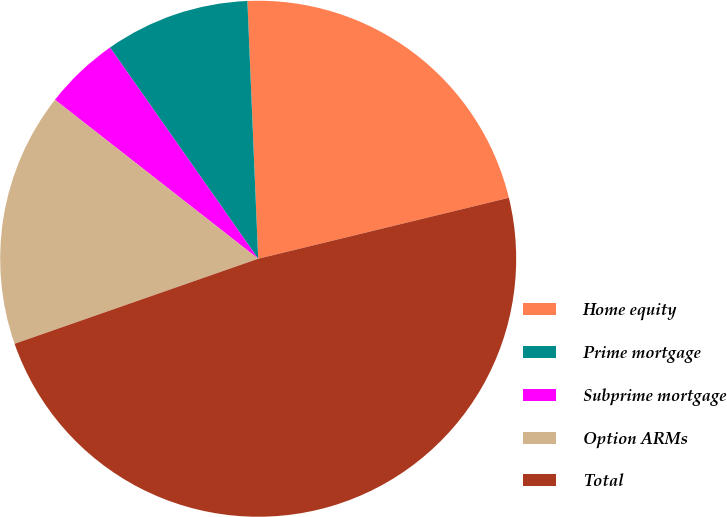<chart> <loc_0><loc_0><loc_500><loc_500><pie_chart><fcel>Home equity<fcel>Prime mortgage<fcel>Subprime mortgage<fcel>Option ARMs<fcel>Total<nl><fcel>21.87%<fcel>9.07%<fcel>4.7%<fcel>15.91%<fcel>48.45%<nl></chart> 